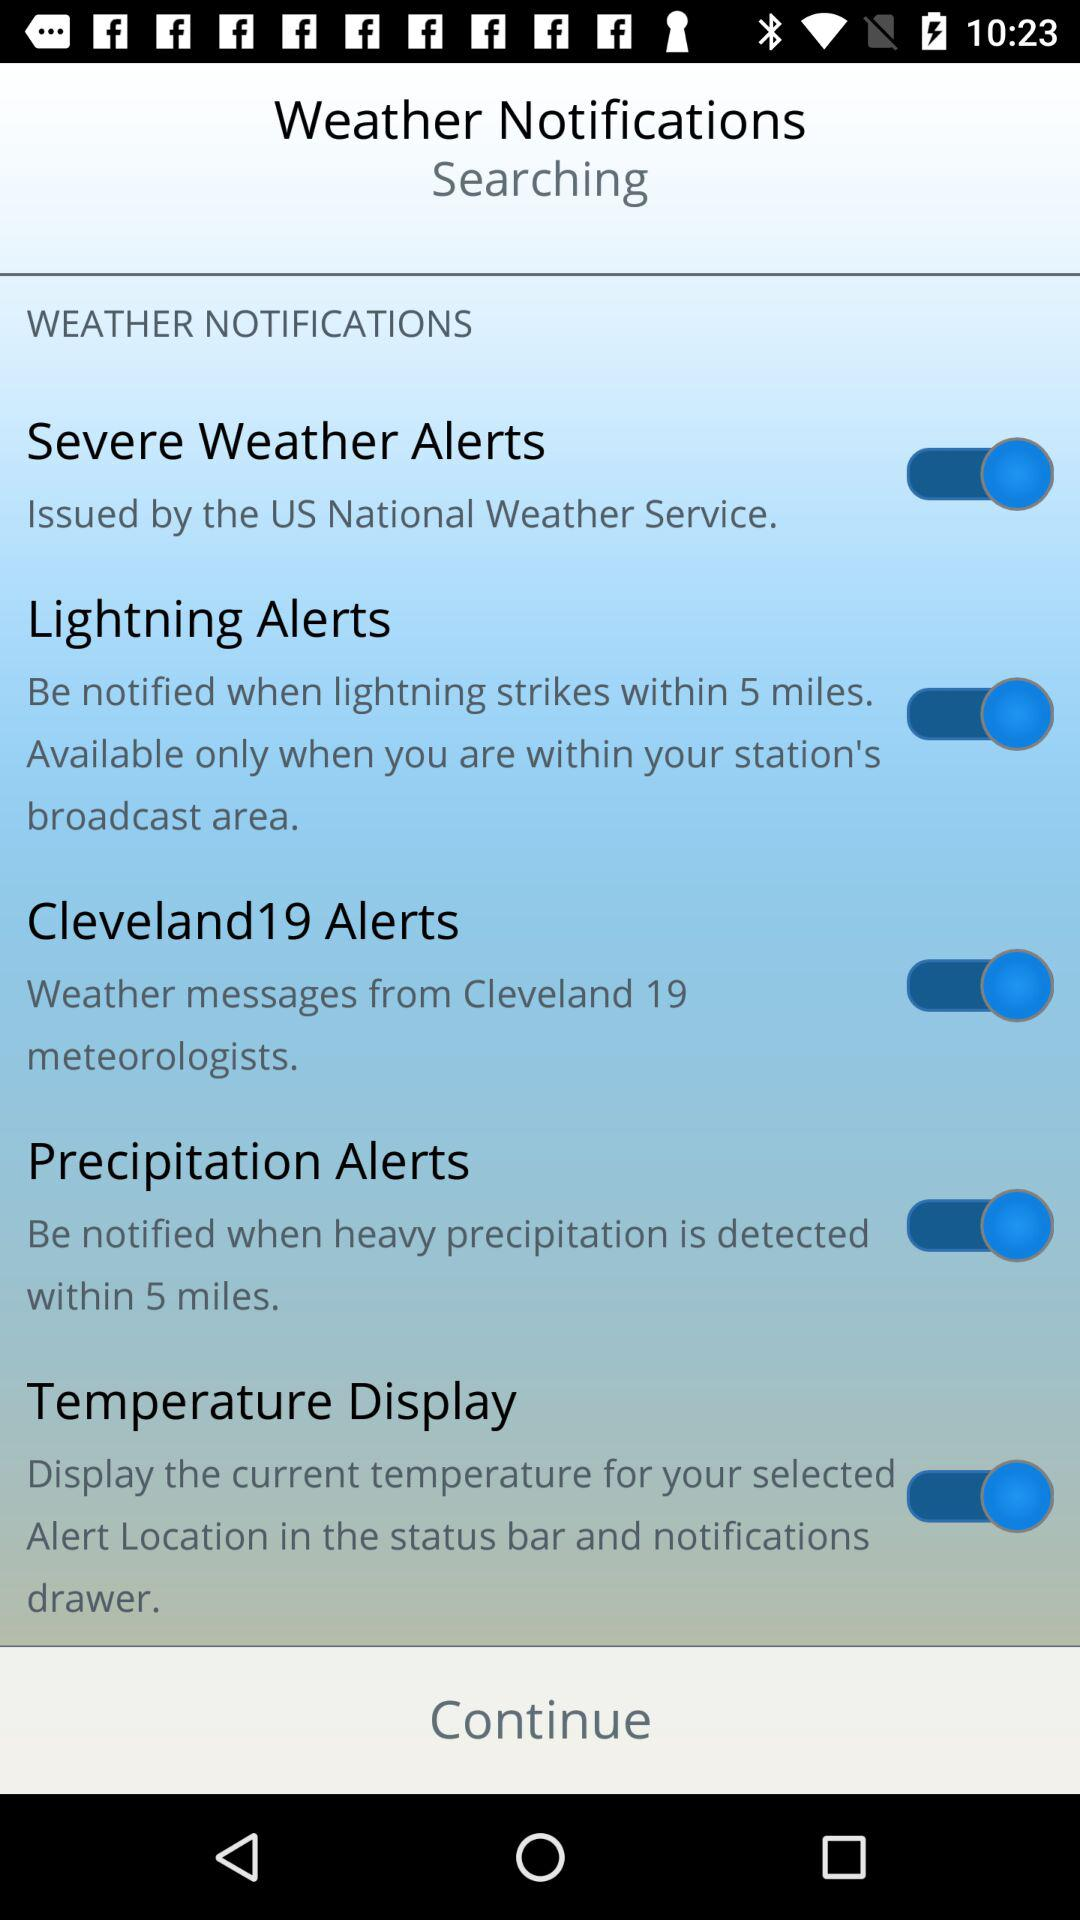What is the status of "Cleveland19 Alerts"? The status is "on". 